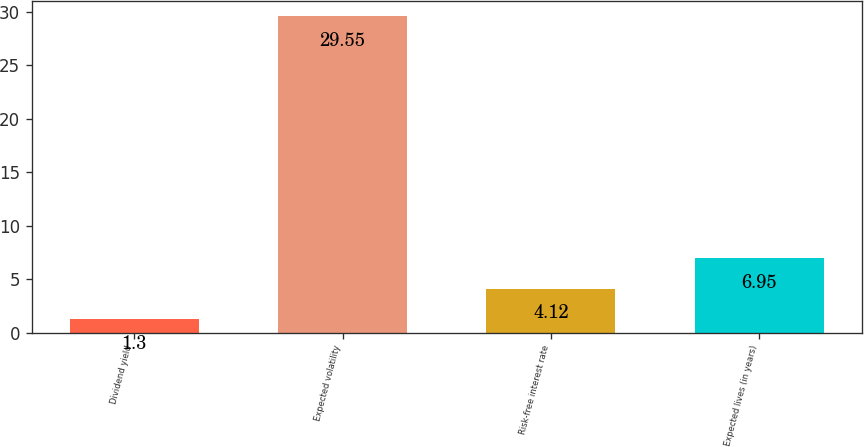Convert chart. <chart><loc_0><loc_0><loc_500><loc_500><bar_chart><fcel>Dividend yield<fcel>Expected volatility<fcel>Risk-free interest rate<fcel>Expected lives (in years)<nl><fcel>1.3<fcel>29.55<fcel>4.12<fcel>6.95<nl></chart> 